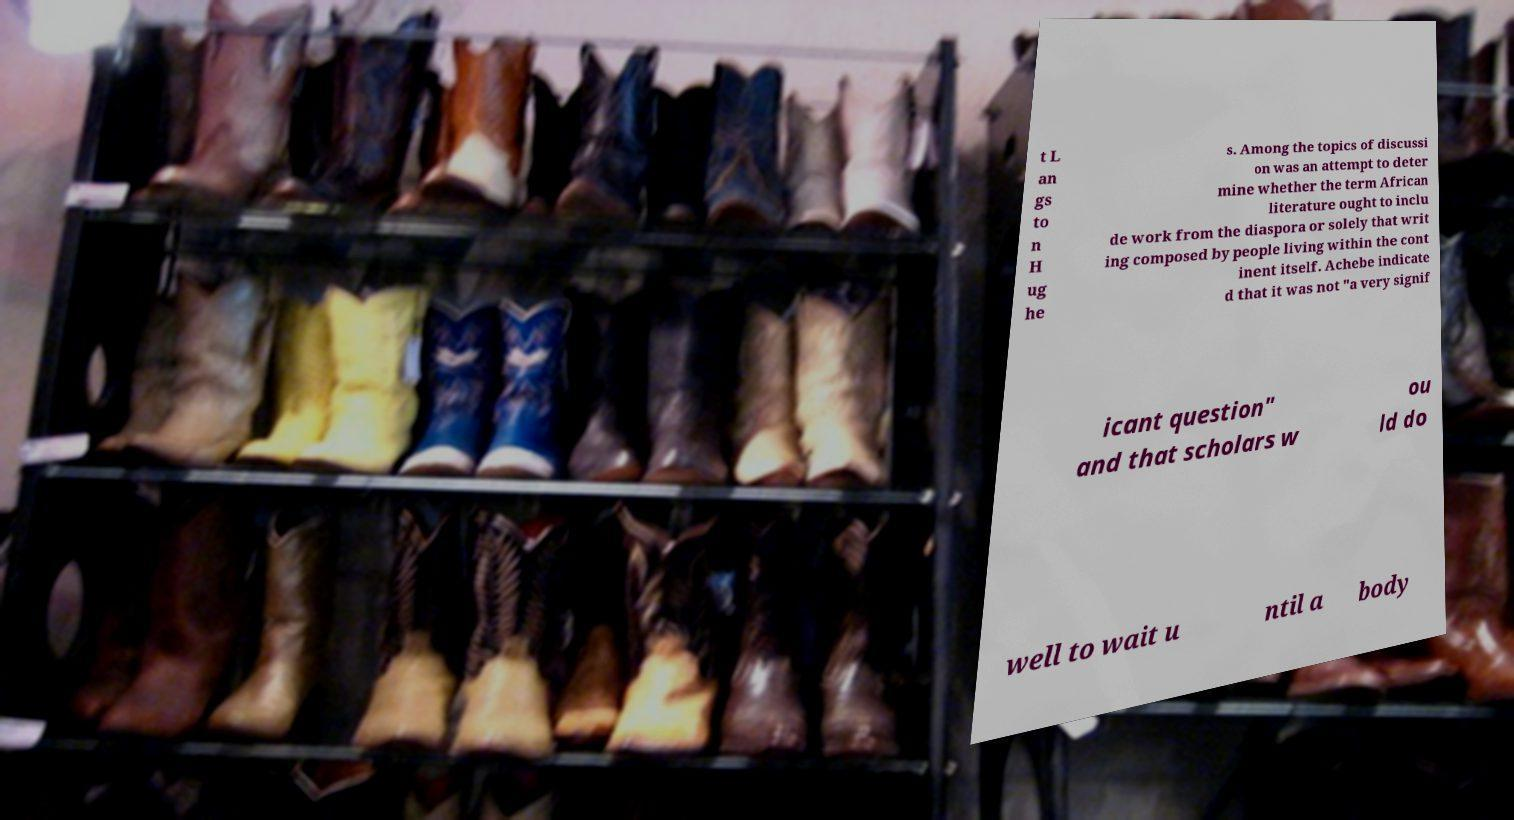For documentation purposes, I need the text within this image transcribed. Could you provide that? t L an gs to n H ug he s. Among the topics of discussi on was an attempt to deter mine whether the term African literature ought to inclu de work from the diaspora or solely that writ ing composed by people living within the cont inent itself. Achebe indicate d that it was not "a very signif icant question" and that scholars w ou ld do well to wait u ntil a body 